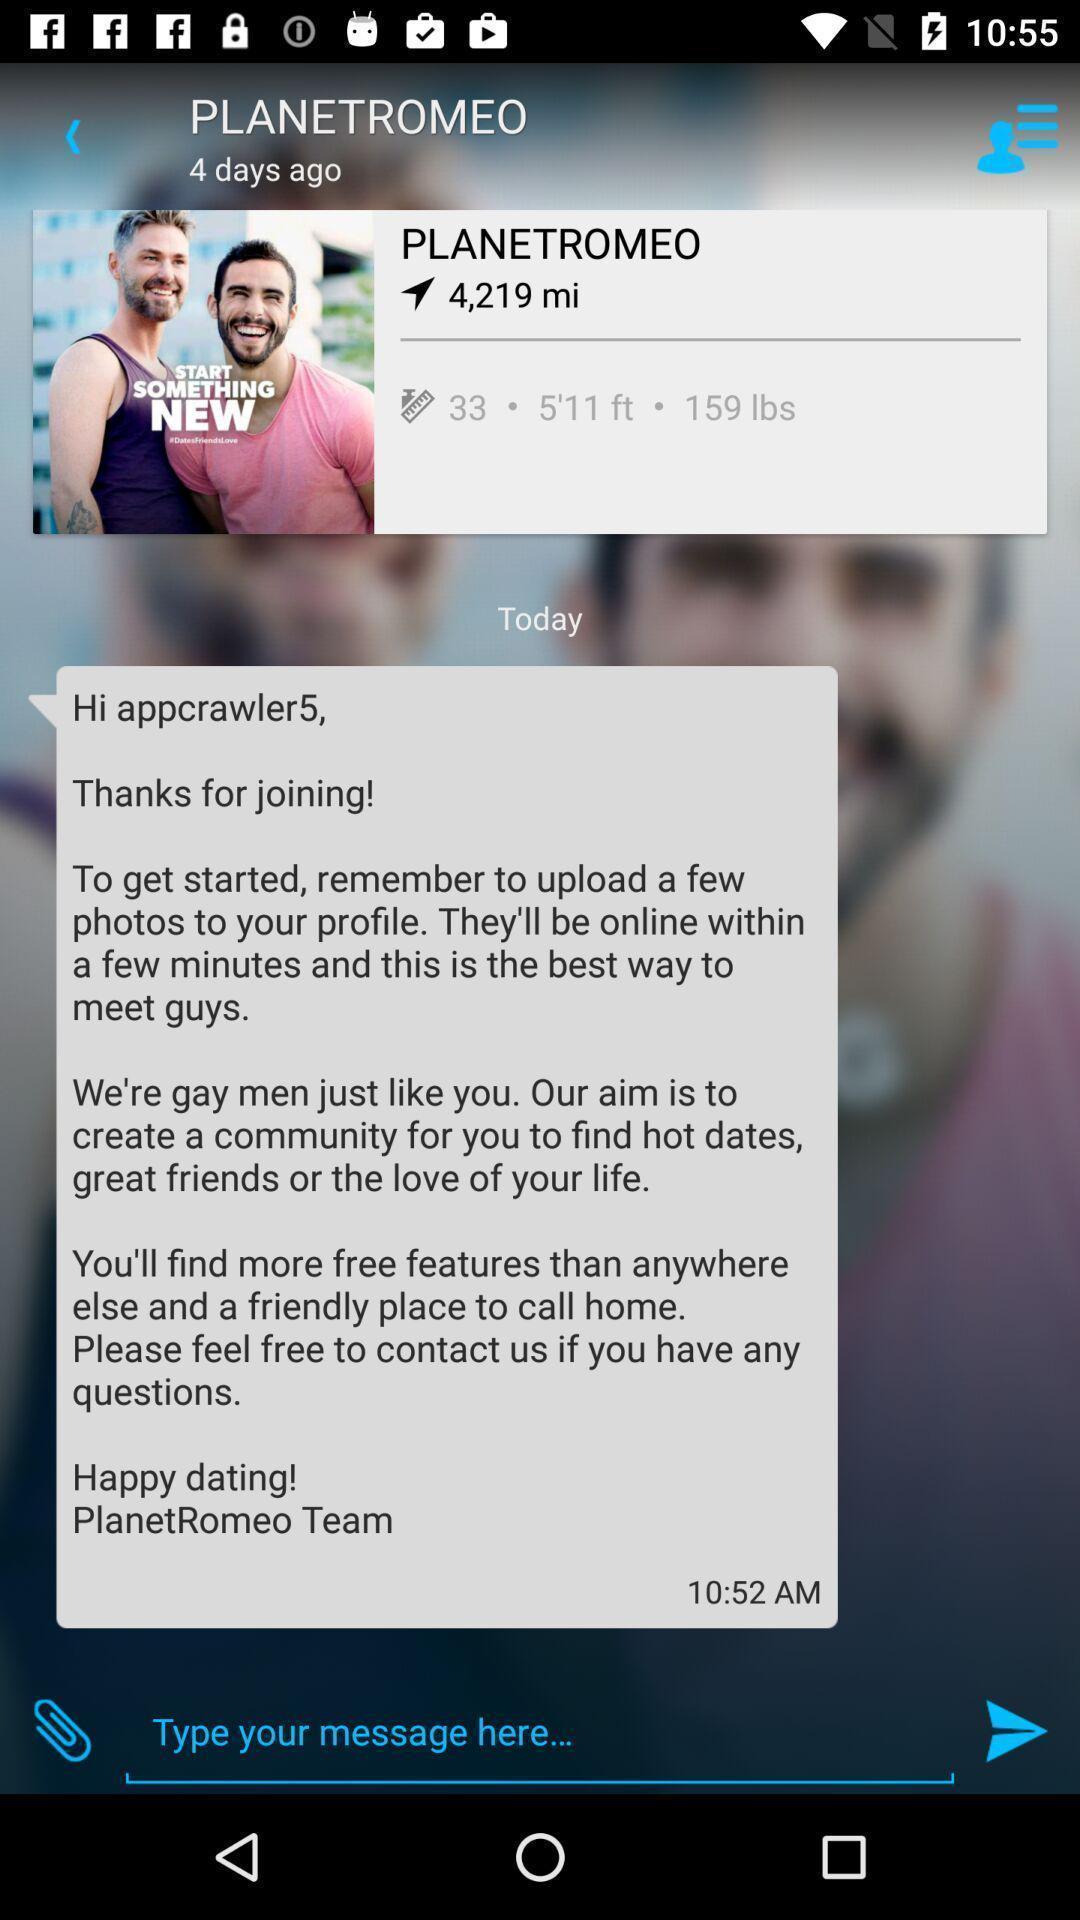What is the overall content of this screenshot? Social app page of personal chat with options. 